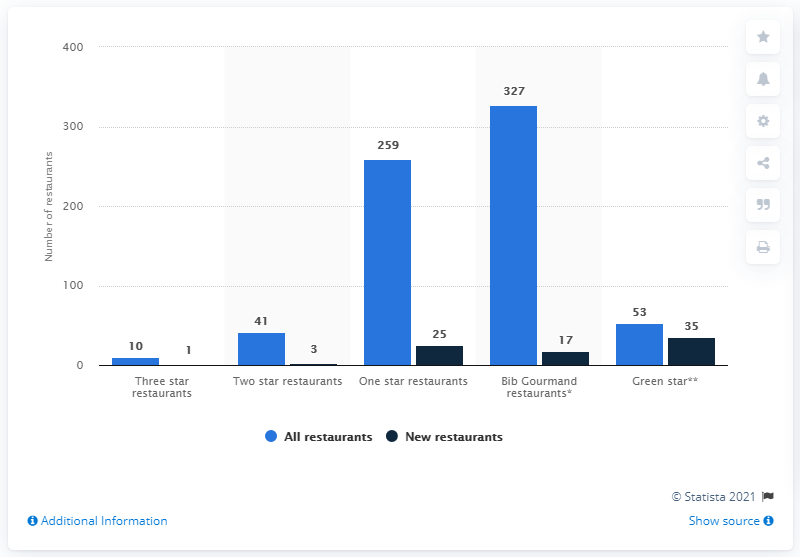Identify some key points in this picture. In 2021, there were 10 three-star restaurants in Germany. 